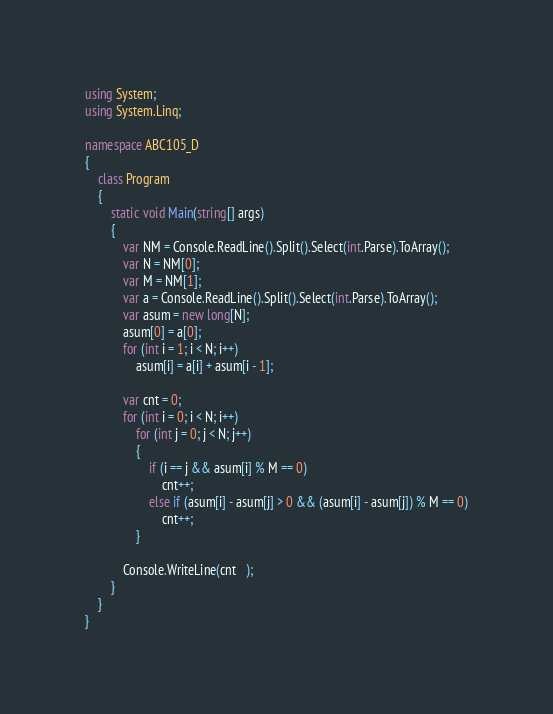Convert code to text. <code><loc_0><loc_0><loc_500><loc_500><_C#_>using System;
using System.Linq;

namespace ABC105_D
{
    class Program
    {
        static void Main(string[] args)
        {
            var NM = Console.ReadLine().Split().Select(int.Parse).ToArray();
            var N = NM[0];
            var M = NM[1];
            var a = Console.ReadLine().Split().Select(int.Parse).ToArray();
            var asum = new long[N];
            asum[0] = a[0];
            for (int i = 1; i < N; i++)
                asum[i] = a[i] + asum[i - 1];

            var cnt = 0;
            for (int i = 0; i < N; i++)
                for (int j = 0; j < N; j++)
                {
                    if (i == j && asum[i] % M == 0)
                        cnt++;
                    else if (asum[i] - asum[j] > 0 && (asum[i] - asum[j]) % M == 0)
                        cnt++;
                }

            Console.WriteLine(cnt   );
        }
    }
}
</code> 